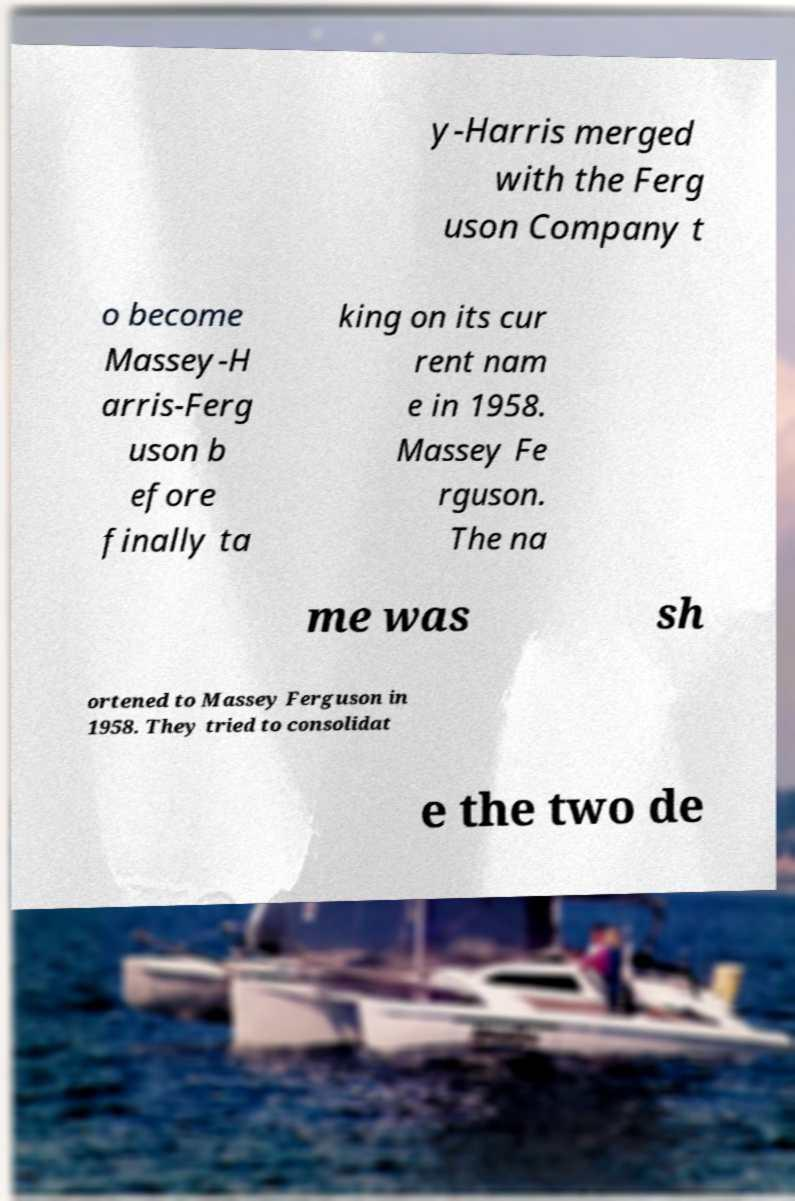Could you extract and type out the text from this image? y-Harris merged with the Ferg uson Company t o become Massey-H arris-Ferg uson b efore finally ta king on its cur rent nam e in 1958. Massey Fe rguson. The na me was sh ortened to Massey Ferguson in 1958. They tried to consolidat e the two de 